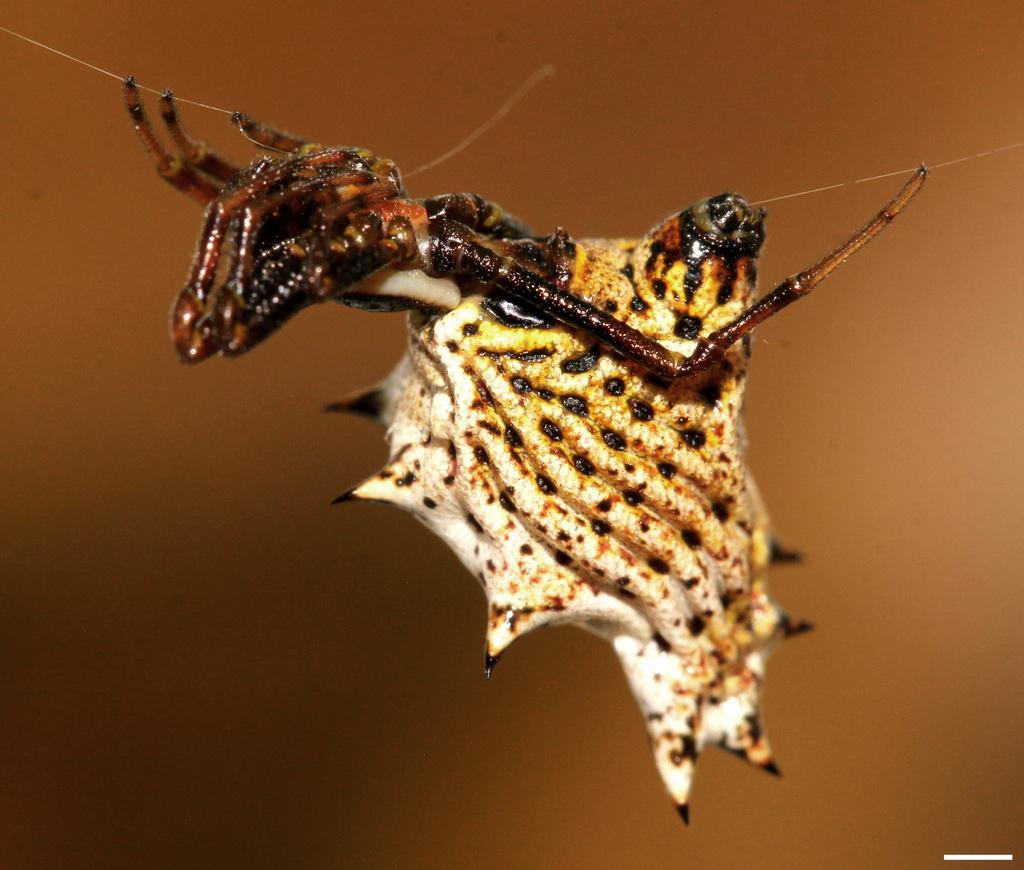Describe this image in one or two sentences. In this picture there is an insect. The background is blurred. 